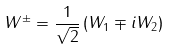Convert formula to latex. <formula><loc_0><loc_0><loc_500><loc_500>W ^ { \pm } = { \frac { 1 } { \sqrt { 2 } } } \left ( W _ { 1 } \mp i W _ { 2 } \right )</formula> 